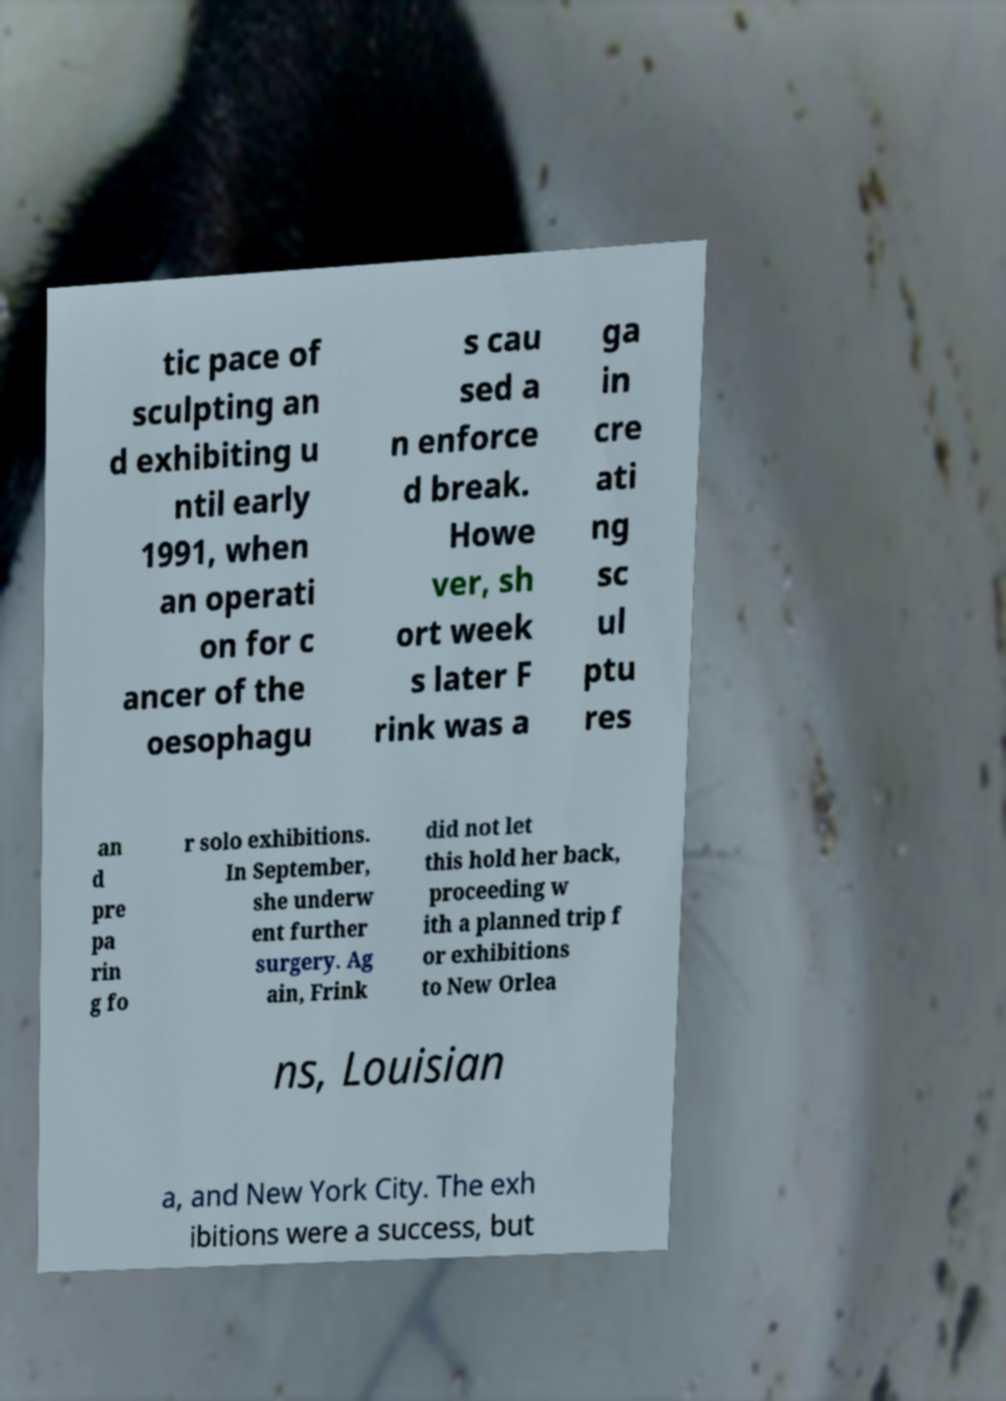Could you assist in decoding the text presented in this image and type it out clearly? tic pace of sculpting an d exhibiting u ntil early 1991, when an operati on for c ancer of the oesophagu s cau sed a n enforce d break. Howe ver, sh ort week s later F rink was a ga in cre ati ng sc ul ptu res an d pre pa rin g fo r solo exhibitions. In September, she underw ent further surgery. Ag ain, Frink did not let this hold her back, proceeding w ith a planned trip f or exhibitions to New Orlea ns, Louisian a, and New York City. The exh ibitions were a success, but 